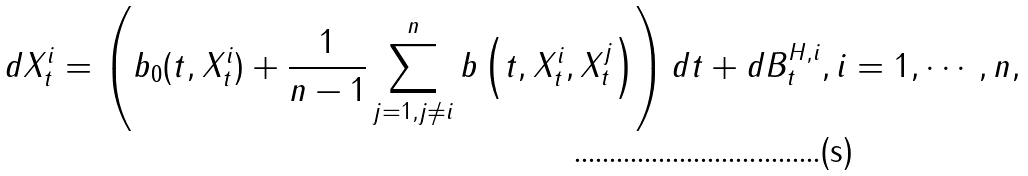<formula> <loc_0><loc_0><loc_500><loc_500>d X _ { t } ^ { i } = \left ( b _ { 0 } ( t , X _ { t } ^ { i } ) + \frac { 1 } { n - 1 } \sum _ { j = 1 , j \neq i } ^ { n } b \left ( t , X _ { t } ^ { i } , X _ { t } ^ { j } \right ) \right ) d t + d B ^ { H , i } _ { t } , i = 1 , \cdots , n ,</formula> 